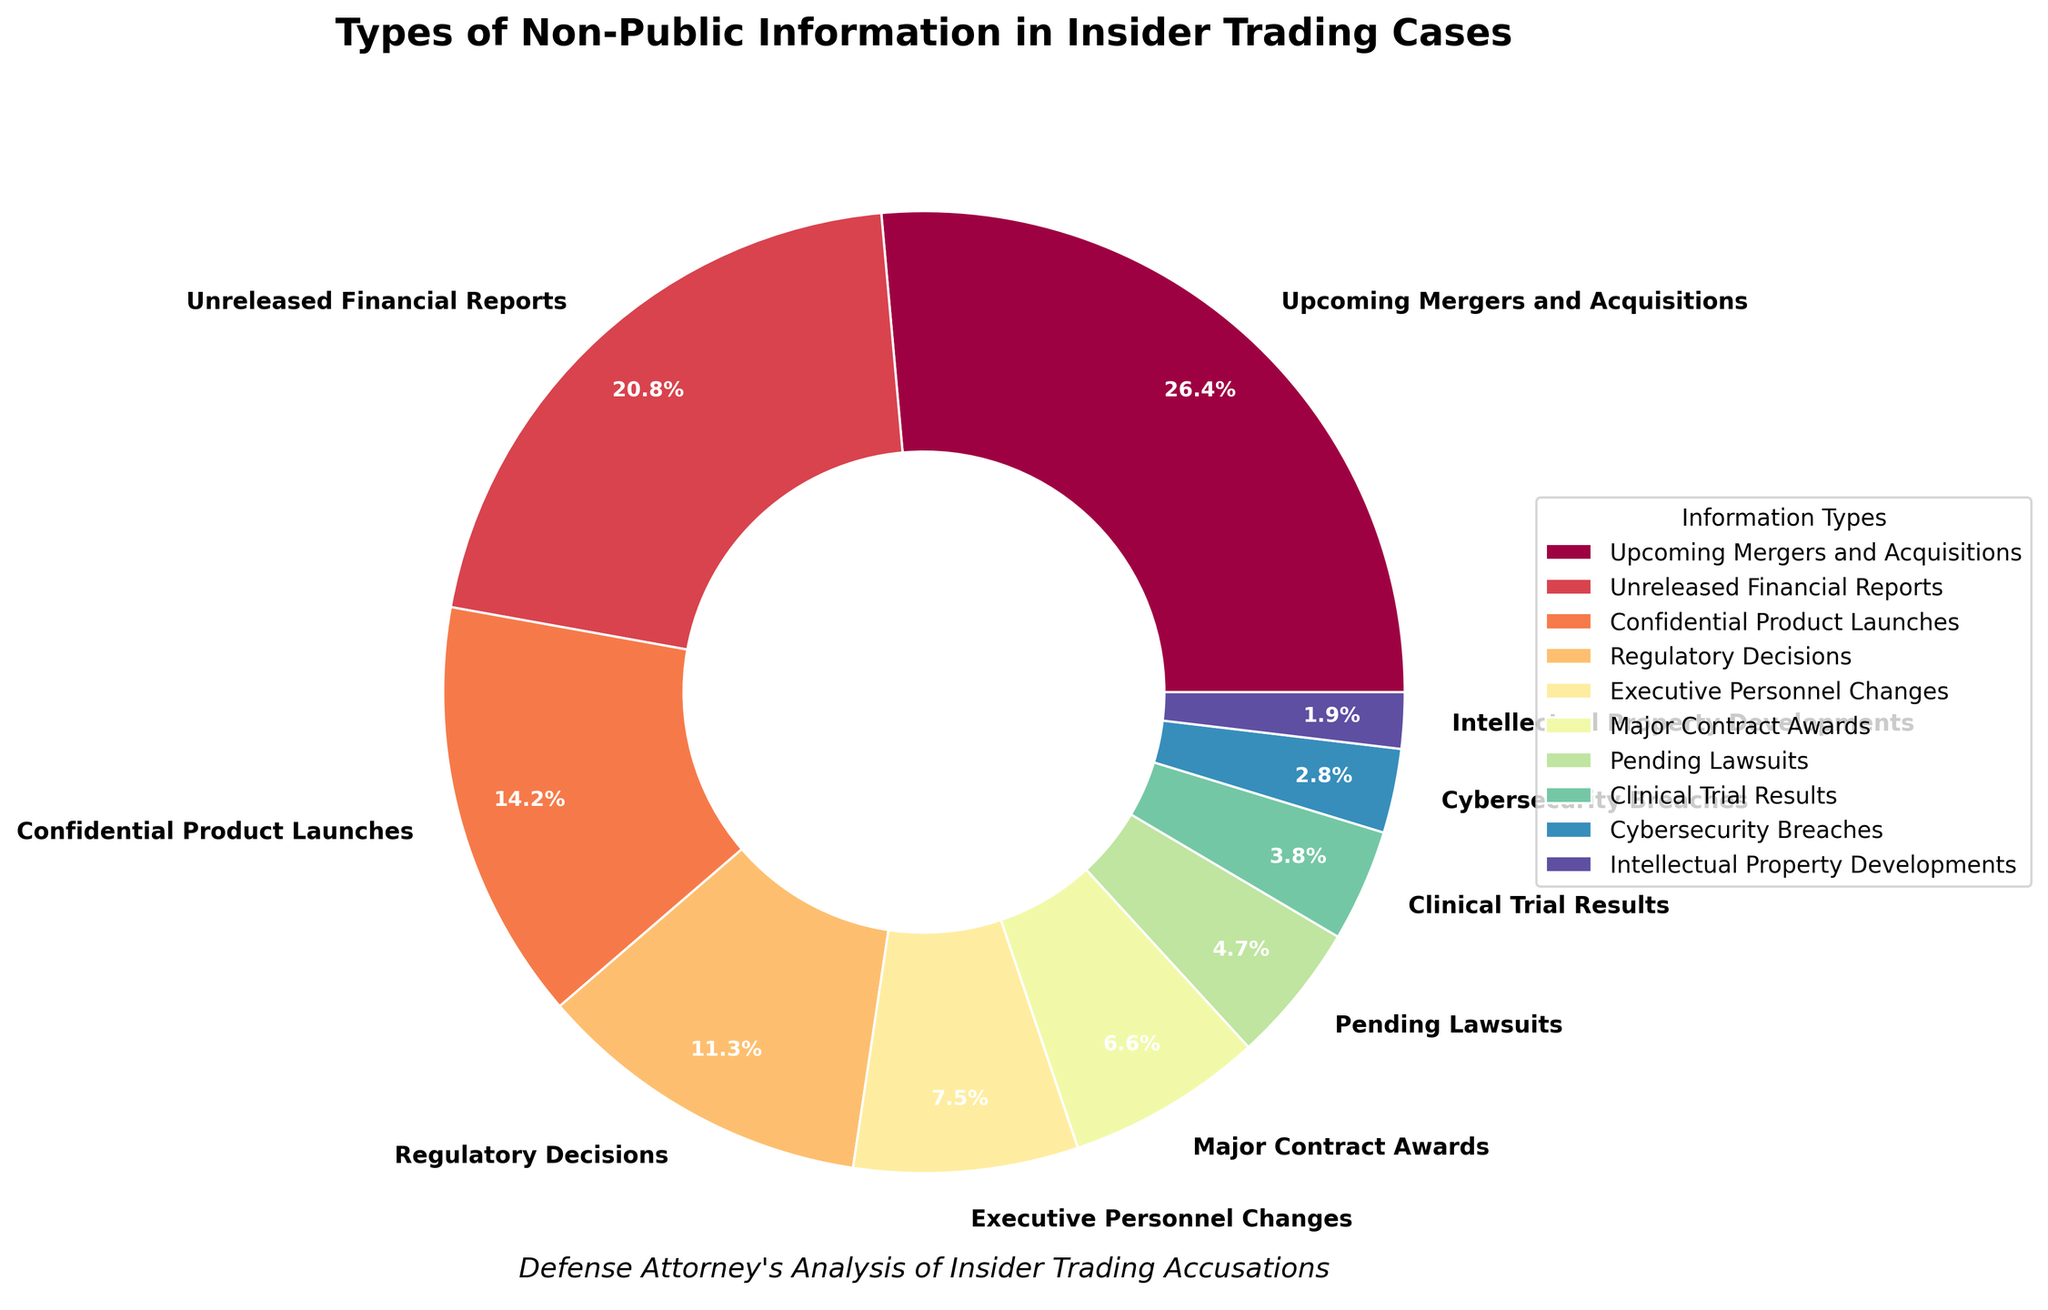What is the most common type of non-public information involved in insider trading cases? The pie chart shows that 'Upcoming Mergers and Acquisitions' has the largest slice, labeled with 28%. This indicates it is the most frequent type of non-public information involved.
Answer: Upcoming Mergers and Acquisitions What is the combined percentage of 'Unreleased Financial Reports' and 'Confidential Product Launches'? 'Unreleased Financial Reports' contributes 22%, and 'Confidential Product Launches' contributes 15%. Adding these together gives 22% + 15% = 37%.
Answer: 37% Which type of non-public information has the smallest involvement in insider trading cases? The smallest slice on the pie chart represents 'Intellectual Property Developments' with a label of 2%.
Answer: Intellectual Property Developments How much greater is the percentage of 'Regulatory Decisions' than 'Pending Lawsuits'? The percentage for 'Regulatory Decisions' is 12%, while 'Pending Lawsuits' is 5%. Subtracting these gives 12% - 5% = 7%.
Answer: 7% Name two types of non-public information whose combined percentage equals the contribution of 'Upcoming Mergers and Acquisitions'. 'Executive Personnel Changes' at 8% and 'Regulatory Decisions' at 12% sum up to 20%. 'Major Contract Awards' at 7% and 'Pending Lawsuits' at 5% also sum up to 12%. Adding them together: 20% + 12% = 32%, which is not equal. For perfect matching, 'Unreleased Financial Reports' at 22% and 'Confidential Product Launches' at 15% sum up to 37%, but we need to meet other combinations.
Answer: Unreleased Financial Reports and Confidential Product Launches What is the visual feature that indicates the highest percentage in the chart? The largest slice in the pie chart indicates the highest percentage, which is colored more prominently and labeled as 'Upcoming Mergers and Acquisitions' with 28%.
Answer: Largest slice Which types of non-public information have percentages less than 10%? The slices for 'Executive Personnel Changes' (8%), 'Major Contract Awards' (7%), 'Pending Lawsuits' (5%), 'Clinical Trial Results' (4%), 'Cybersecurity Breaches' (3%), and 'Intellectual Property Developments' (2%) all fall below 10%.
Answer: Executive Personnel Changes, Major Contract Awards, Pending Lawsuits, Clinical Trial Results, Cybersecurity Breaches, Intellectual Property Developments What is the difference between the percentages of 'Executive Personnel Changes' and 'Major Contract Awards'? 'Executive Personnel Changes' is at 8%, and 'Major Contract Awards' is at 7%. Subtracting these, we get 8% - 7% = 1%.
Answer: 1% If the top three categories are combined, what percentage of insider trading cases do they account for? The percentages for 'Upcoming Mergers and Acquisitions' (28%), 'Unreleased Financial Reports' (22%), and 'Confidential Product Launches' (15%) are combined to give 28% + 22% + 15% = 65%.
Answer: 65% 